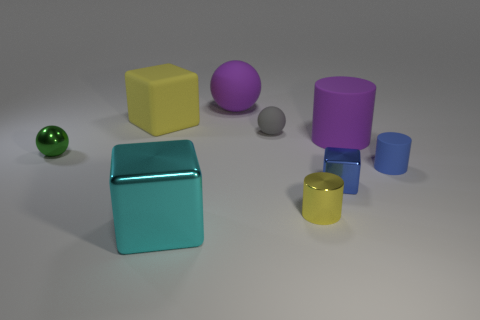Add 1 big green matte spheres. How many objects exist? 10 Subtract all cylinders. How many objects are left? 6 Add 5 tiny blue metallic spheres. How many tiny blue metallic spheres exist? 5 Subtract 0 red cubes. How many objects are left? 9 Subtract all tiny gray metallic cylinders. Subtract all small matte spheres. How many objects are left? 8 Add 3 tiny spheres. How many tiny spheres are left? 5 